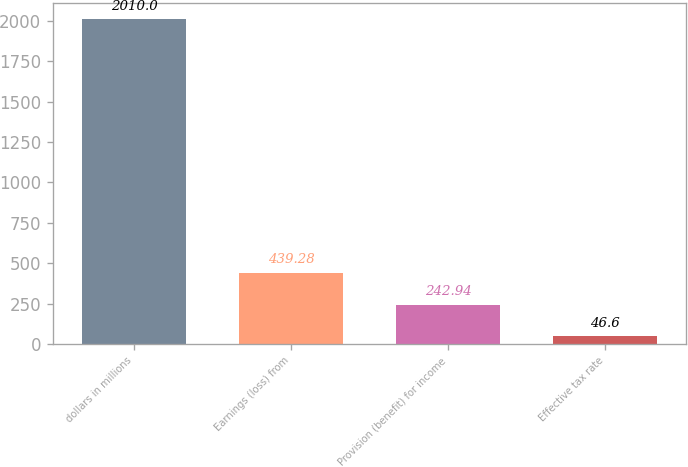Convert chart. <chart><loc_0><loc_0><loc_500><loc_500><bar_chart><fcel>dollars in millions<fcel>Earnings (loss) from<fcel>Provision (benefit) for income<fcel>Effective tax rate<nl><fcel>2010<fcel>439.28<fcel>242.94<fcel>46.6<nl></chart> 